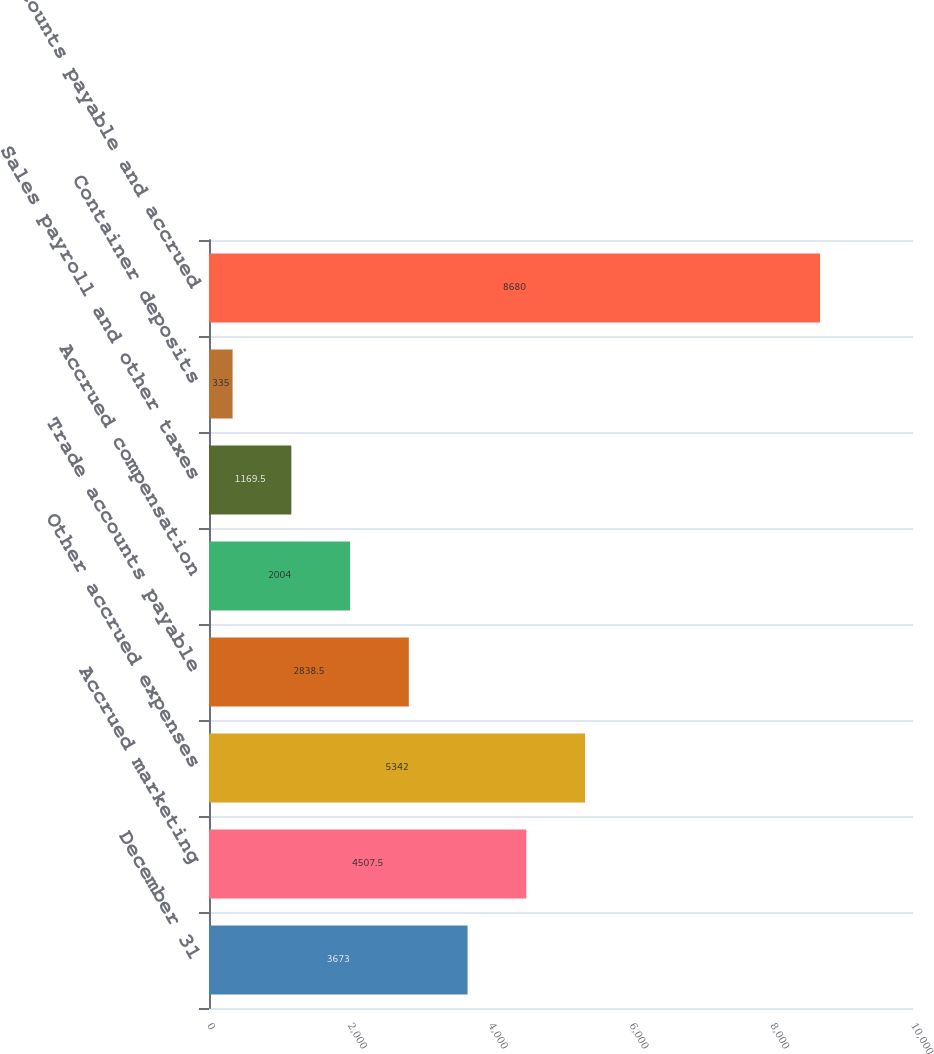Convert chart to OTSL. <chart><loc_0><loc_0><loc_500><loc_500><bar_chart><fcel>December 31<fcel>Accrued marketing<fcel>Other accrued expenses<fcel>Trade accounts payable<fcel>Accrued compensation<fcel>Sales payroll and other taxes<fcel>Container deposits<fcel>Accounts payable and accrued<nl><fcel>3673<fcel>4507.5<fcel>5342<fcel>2838.5<fcel>2004<fcel>1169.5<fcel>335<fcel>8680<nl></chart> 